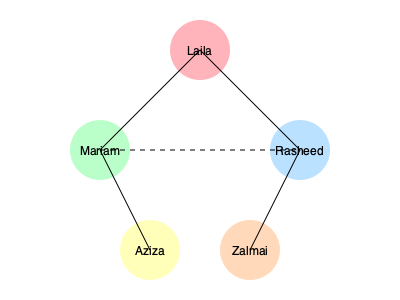Based on the network diagram illustrating character relationships in Khaled Hosseini's "A Thousand Splendid Suns," what can be inferred about the central character's role in the novel? To answer this question, let's analyze the network diagram step-by-step:

1. The diagram shows five characters: Laila, Mariam, Rasheed, Aziza, and Zalmai.

2. Laila is positioned at the top of the diagram, suggesting she may be a central or pivotal character.

3. Laila has direct connections to four other characters:
   a. Mariam
   b. Rasheed
   c. Aziza (indirectly through Mariam)
   d. Zalmai (indirectly through Rasheed)

4. The solid lines indicate strong or direct relationships, while the dashed line between Mariam and Rasheed suggests a more complex or strained relationship.

5. Laila's position and connections indicate that she interacts with or influences all other characters in the diagram.

6. The structure of the diagram resembles a family tree, with Laila at the top, suggesting she might be a connecting force between two generations or family units.

Given these observations, we can infer that Laila plays a central role in the novel, acting as a bridge between different characters and storylines. Her position suggests she may be the protagonist or a key character through whom the narrative unfolds, connecting the lives of the other characters and potentially influencing the course of events in the story.
Answer: Central protagonist connecting multiple characters and storylines 